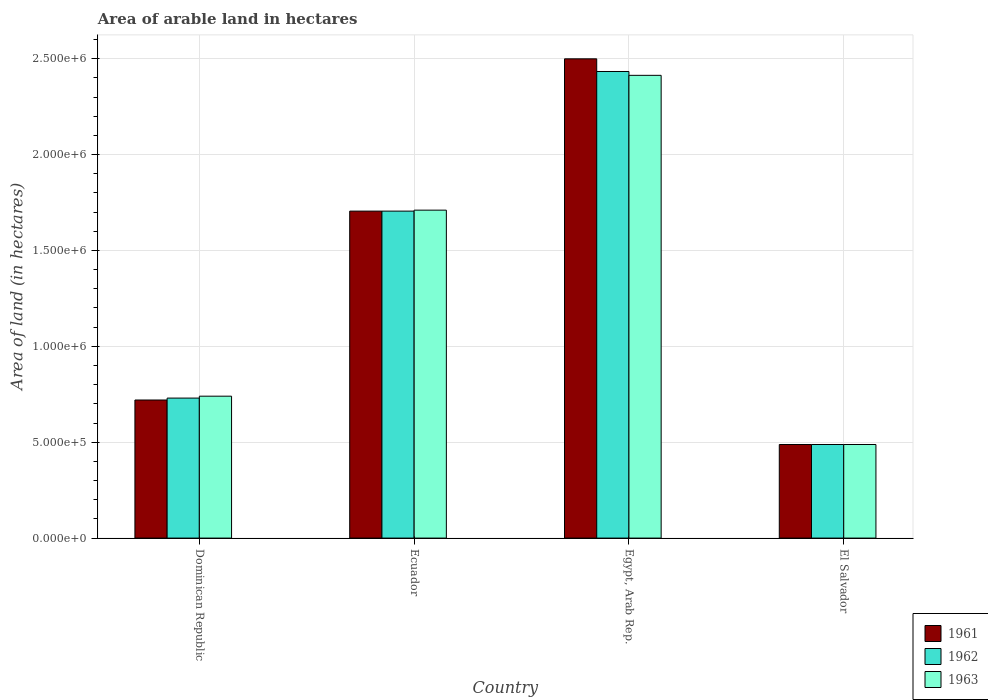How many groups of bars are there?
Provide a succinct answer. 4. How many bars are there on the 1st tick from the left?
Give a very brief answer. 3. What is the label of the 1st group of bars from the left?
Provide a short and direct response. Dominican Republic. In how many cases, is the number of bars for a given country not equal to the number of legend labels?
Your answer should be very brief. 0. What is the total arable land in 1963 in Dominican Republic?
Keep it short and to the point. 7.40e+05. Across all countries, what is the maximum total arable land in 1963?
Your response must be concise. 2.41e+06. Across all countries, what is the minimum total arable land in 1962?
Give a very brief answer. 4.88e+05. In which country was the total arable land in 1961 maximum?
Offer a very short reply. Egypt, Arab Rep. In which country was the total arable land in 1963 minimum?
Keep it short and to the point. El Salvador. What is the total total arable land in 1961 in the graph?
Offer a terse response. 5.41e+06. What is the difference between the total arable land in 1962 in Dominican Republic and that in Egypt, Arab Rep.?
Give a very brief answer. -1.70e+06. What is the difference between the total arable land in 1962 in El Salvador and the total arable land in 1963 in Ecuador?
Your answer should be compact. -1.22e+06. What is the average total arable land in 1962 per country?
Offer a terse response. 1.34e+06. What is the difference between the total arable land of/in 1963 and total arable land of/in 1961 in El Salvador?
Provide a succinct answer. 0. In how many countries, is the total arable land in 1962 greater than 2400000 hectares?
Offer a terse response. 1. What is the ratio of the total arable land in 1963 in Dominican Republic to that in El Salvador?
Provide a short and direct response. 1.52. What is the difference between the highest and the second highest total arable land in 1962?
Your response must be concise. 7.28e+05. What is the difference between the highest and the lowest total arable land in 1962?
Provide a short and direct response. 1.94e+06. Is the sum of the total arable land in 1961 in Dominican Republic and El Salvador greater than the maximum total arable land in 1962 across all countries?
Ensure brevity in your answer.  No. What does the 2nd bar from the right in Ecuador represents?
Make the answer very short. 1962. Is it the case that in every country, the sum of the total arable land in 1961 and total arable land in 1962 is greater than the total arable land in 1963?
Ensure brevity in your answer.  Yes. How many countries are there in the graph?
Offer a terse response. 4. Are the values on the major ticks of Y-axis written in scientific E-notation?
Give a very brief answer. Yes. Does the graph contain any zero values?
Give a very brief answer. No. Does the graph contain grids?
Provide a short and direct response. Yes. Where does the legend appear in the graph?
Your answer should be very brief. Bottom right. How are the legend labels stacked?
Offer a very short reply. Vertical. What is the title of the graph?
Ensure brevity in your answer.  Area of arable land in hectares. What is the label or title of the Y-axis?
Offer a very short reply. Area of land (in hectares). What is the Area of land (in hectares) in 1961 in Dominican Republic?
Your answer should be very brief. 7.20e+05. What is the Area of land (in hectares) of 1962 in Dominican Republic?
Keep it short and to the point. 7.30e+05. What is the Area of land (in hectares) in 1963 in Dominican Republic?
Make the answer very short. 7.40e+05. What is the Area of land (in hectares) of 1961 in Ecuador?
Give a very brief answer. 1.70e+06. What is the Area of land (in hectares) of 1962 in Ecuador?
Keep it short and to the point. 1.70e+06. What is the Area of land (in hectares) in 1963 in Ecuador?
Offer a terse response. 1.71e+06. What is the Area of land (in hectares) of 1961 in Egypt, Arab Rep.?
Offer a terse response. 2.50e+06. What is the Area of land (in hectares) in 1962 in Egypt, Arab Rep.?
Make the answer very short. 2.43e+06. What is the Area of land (in hectares) in 1963 in Egypt, Arab Rep.?
Your answer should be compact. 2.41e+06. What is the Area of land (in hectares) of 1961 in El Salvador?
Provide a short and direct response. 4.88e+05. What is the Area of land (in hectares) in 1962 in El Salvador?
Make the answer very short. 4.88e+05. What is the Area of land (in hectares) in 1963 in El Salvador?
Your response must be concise. 4.88e+05. Across all countries, what is the maximum Area of land (in hectares) of 1961?
Provide a succinct answer. 2.50e+06. Across all countries, what is the maximum Area of land (in hectares) in 1962?
Your response must be concise. 2.43e+06. Across all countries, what is the maximum Area of land (in hectares) in 1963?
Give a very brief answer. 2.41e+06. Across all countries, what is the minimum Area of land (in hectares) of 1961?
Your answer should be compact. 4.88e+05. Across all countries, what is the minimum Area of land (in hectares) of 1962?
Your response must be concise. 4.88e+05. Across all countries, what is the minimum Area of land (in hectares) in 1963?
Offer a terse response. 4.88e+05. What is the total Area of land (in hectares) of 1961 in the graph?
Offer a very short reply. 5.41e+06. What is the total Area of land (in hectares) of 1962 in the graph?
Make the answer very short. 5.36e+06. What is the total Area of land (in hectares) in 1963 in the graph?
Provide a succinct answer. 5.35e+06. What is the difference between the Area of land (in hectares) in 1961 in Dominican Republic and that in Ecuador?
Offer a very short reply. -9.85e+05. What is the difference between the Area of land (in hectares) of 1962 in Dominican Republic and that in Ecuador?
Provide a short and direct response. -9.75e+05. What is the difference between the Area of land (in hectares) in 1963 in Dominican Republic and that in Ecuador?
Your answer should be compact. -9.70e+05. What is the difference between the Area of land (in hectares) in 1961 in Dominican Republic and that in Egypt, Arab Rep.?
Your response must be concise. -1.78e+06. What is the difference between the Area of land (in hectares) of 1962 in Dominican Republic and that in Egypt, Arab Rep.?
Keep it short and to the point. -1.70e+06. What is the difference between the Area of land (in hectares) of 1963 in Dominican Republic and that in Egypt, Arab Rep.?
Ensure brevity in your answer.  -1.67e+06. What is the difference between the Area of land (in hectares) of 1961 in Dominican Republic and that in El Salvador?
Your answer should be very brief. 2.32e+05. What is the difference between the Area of land (in hectares) of 1962 in Dominican Republic and that in El Salvador?
Make the answer very short. 2.42e+05. What is the difference between the Area of land (in hectares) of 1963 in Dominican Republic and that in El Salvador?
Make the answer very short. 2.52e+05. What is the difference between the Area of land (in hectares) in 1961 in Ecuador and that in Egypt, Arab Rep.?
Offer a very short reply. -7.94e+05. What is the difference between the Area of land (in hectares) of 1962 in Ecuador and that in Egypt, Arab Rep.?
Give a very brief answer. -7.28e+05. What is the difference between the Area of land (in hectares) of 1963 in Ecuador and that in Egypt, Arab Rep.?
Provide a succinct answer. -7.03e+05. What is the difference between the Area of land (in hectares) in 1961 in Ecuador and that in El Salvador?
Offer a terse response. 1.22e+06. What is the difference between the Area of land (in hectares) of 1962 in Ecuador and that in El Salvador?
Make the answer very short. 1.22e+06. What is the difference between the Area of land (in hectares) in 1963 in Ecuador and that in El Salvador?
Your answer should be compact. 1.22e+06. What is the difference between the Area of land (in hectares) of 1961 in Egypt, Arab Rep. and that in El Salvador?
Your response must be concise. 2.01e+06. What is the difference between the Area of land (in hectares) in 1962 in Egypt, Arab Rep. and that in El Salvador?
Provide a short and direct response. 1.94e+06. What is the difference between the Area of land (in hectares) of 1963 in Egypt, Arab Rep. and that in El Salvador?
Provide a short and direct response. 1.92e+06. What is the difference between the Area of land (in hectares) of 1961 in Dominican Republic and the Area of land (in hectares) of 1962 in Ecuador?
Provide a short and direct response. -9.85e+05. What is the difference between the Area of land (in hectares) in 1961 in Dominican Republic and the Area of land (in hectares) in 1963 in Ecuador?
Ensure brevity in your answer.  -9.90e+05. What is the difference between the Area of land (in hectares) of 1962 in Dominican Republic and the Area of land (in hectares) of 1963 in Ecuador?
Your response must be concise. -9.80e+05. What is the difference between the Area of land (in hectares) in 1961 in Dominican Republic and the Area of land (in hectares) in 1962 in Egypt, Arab Rep.?
Offer a terse response. -1.71e+06. What is the difference between the Area of land (in hectares) in 1961 in Dominican Republic and the Area of land (in hectares) in 1963 in Egypt, Arab Rep.?
Your answer should be very brief. -1.69e+06. What is the difference between the Area of land (in hectares) of 1962 in Dominican Republic and the Area of land (in hectares) of 1963 in Egypt, Arab Rep.?
Your answer should be compact. -1.68e+06. What is the difference between the Area of land (in hectares) of 1961 in Dominican Republic and the Area of land (in hectares) of 1962 in El Salvador?
Offer a terse response. 2.32e+05. What is the difference between the Area of land (in hectares) of 1961 in Dominican Republic and the Area of land (in hectares) of 1963 in El Salvador?
Provide a short and direct response. 2.32e+05. What is the difference between the Area of land (in hectares) of 1962 in Dominican Republic and the Area of land (in hectares) of 1963 in El Salvador?
Give a very brief answer. 2.42e+05. What is the difference between the Area of land (in hectares) in 1961 in Ecuador and the Area of land (in hectares) in 1962 in Egypt, Arab Rep.?
Ensure brevity in your answer.  -7.28e+05. What is the difference between the Area of land (in hectares) of 1961 in Ecuador and the Area of land (in hectares) of 1963 in Egypt, Arab Rep.?
Make the answer very short. -7.08e+05. What is the difference between the Area of land (in hectares) of 1962 in Ecuador and the Area of land (in hectares) of 1963 in Egypt, Arab Rep.?
Ensure brevity in your answer.  -7.08e+05. What is the difference between the Area of land (in hectares) in 1961 in Ecuador and the Area of land (in hectares) in 1962 in El Salvador?
Give a very brief answer. 1.22e+06. What is the difference between the Area of land (in hectares) of 1961 in Ecuador and the Area of land (in hectares) of 1963 in El Salvador?
Make the answer very short. 1.22e+06. What is the difference between the Area of land (in hectares) in 1962 in Ecuador and the Area of land (in hectares) in 1963 in El Salvador?
Your answer should be compact. 1.22e+06. What is the difference between the Area of land (in hectares) in 1961 in Egypt, Arab Rep. and the Area of land (in hectares) in 1962 in El Salvador?
Your response must be concise. 2.01e+06. What is the difference between the Area of land (in hectares) in 1961 in Egypt, Arab Rep. and the Area of land (in hectares) in 1963 in El Salvador?
Ensure brevity in your answer.  2.01e+06. What is the difference between the Area of land (in hectares) in 1962 in Egypt, Arab Rep. and the Area of land (in hectares) in 1963 in El Salvador?
Your answer should be compact. 1.94e+06. What is the average Area of land (in hectares) of 1961 per country?
Provide a short and direct response. 1.35e+06. What is the average Area of land (in hectares) in 1962 per country?
Provide a succinct answer. 1.34e+06. What is the average Area of land (in hectares) of 1963 per country?
Ensure brevity in your answer.  1.34e+06. What is the difference between the Area of land (in hectares) in 1961 and Area of land (in hectares) in 1962 in Ecuador?
Ensure brevity in your answer.  0. What is the difference between the Area of land (in hectares) of 1961 and Area of land (in hectares) of 1963 in Ecuador?
Offer a terse response. -5000. What is the difference between the Area of land (in hectares) of 1962 and Area of land (in hectares) of 1963 in Ecuador?
Provide a succinct answer. -5000. What is the difference between the Area of land (in hectares) in 1961 and Area of land (in hectares) in 1962 in Egypt, Arab Rep.?
Give a very brief answer. 6.60e+04. What is the difference between the Area of land (in hectares) in 1961 and Area of land (in hectares) in 1963 in Egypt, Arab Rep.?
Keep it short and to the point. 8.60e+04. What is the difference between the Area of land (in hectares) of 1962 and Area of land (in hectares) of 1963 in Egypt, Arab Rep.?
Offer a terse response. 2.00e+04. What is the difference between the Area of land (in hectares) of 1961 and Area of land (in hectares) of 1962 in El Salvador?
Keep it short and to the point. 0. What is the difference between the Area of land (in hectares) of 1961 and Area of land (in hectares) of 1963 in El Salvador?
Provide a short and direct response. 0. What is the ratio of the Area of land (in hectares) in 1961 in Dominican Republic to that in Ecuador?
Make the answer very short. 0.42. What is the ratio of the Area of land (in hectares) in 1962 in Dominican Republic to that in Ecuador?
Provide a short and direct response. 0.43. What is the ratio of the Area of land (in hectares) of 1963 in Dominican Republic to that in Ecuador?
Offer a very short reply. 0.43. What is the ratio of the Area of land (in hectares) of 1961 in Dominican Republic to that in Egypt, Arab Rep.?
Keep it short and to the point. 0.29. What is the ratio of the Area of land (in hectares) in 1963 in Dominican Republic to that in Egypt, Arab Rep.?
Provide a succinct answer. 0.31. What is the ratio of the Area of land (in hectares) in 1961 in Dominican Republic to that in El Salvador?
Offer a very short reply. 1.48. What is the ratio of the Area of land (in hectares) in 1962 in Dominican Republic to that in El Salvador?
Ensure brevity in your answer.  1.5. What is the ratio of the Area of land (in hectares) in 1963 in Dominican Republic to that in El Salvador?
Offer a very short reply. 1.52. What is the ratio of the Area of land (in hectares) of 1961 in Ecuador to that in Egypt, Arab Rep.?
Make the answer very short. 0.68. What is the ratio of the Area of land (in hectares) in 1962 in Ecuador to that in Egypt, Arab Rep.?
Keep it short and to the point. 0.7. What is the ratio of the Area of land (in hectares) of 1963 in Ecuador to that in Egypt, Arab Rep.?
Your answer should be compact. 0.71. What is the ratio of the Area of land (in hectares) of 1961 in Ecuador to that in El Salvador?
Your answer should be very brief. 3.49. What is the ratio of the Area of land (in hectares) of 1962 in Ecuador to that in El Salvador?
Make the answer very short. 3.49. What is the ratio of the Area of land (in hectares) of 1963 in Ecuador to that in El Salvador?
Give a very brief answer. 3.5. What is the ratio of the Area of land (in hectares) in 1961 in Egypt, Arab Rep. to that in El Salvador?
Your answer should be very brief. 5.12. What is the ratio of the Area of land (in hectares) in 1962 in Egypt, Arab Rep. to that in El Salvador?
Your answer should be very brief. 4.99. What is the ratio of the Area of land (in hectares) of 1963 in Egypt, Arab Rep. to that in El Salvador?
Your answer should be very brief. 4.94. What is the difference between the highest and the second highest Area of land (in hectares) in 1961?
Your response must be concise. 7.94e+05. What is the difference between the highest and the second highest Area of land (in hectares) in 1962?
Make the answer very short. 7.28e+05. What is the difference between the highest and the second highest Area of land (in hectares) of 1963?
Your answer should be compact. 7.03e+05. What is the difference between the highest and the lowest Area of land (in hectares) of 1961?
Ensure brevity in your answer.  2.01e+06. What is the difference between the highest and the lowest Area of land (in hectares) of 1962?
Your response must be concise. 1.94e+06. What is the difference between the highest and the lowest Area of land (in hectares) in 1963?
Your response must be concise. 1.92e+06. 